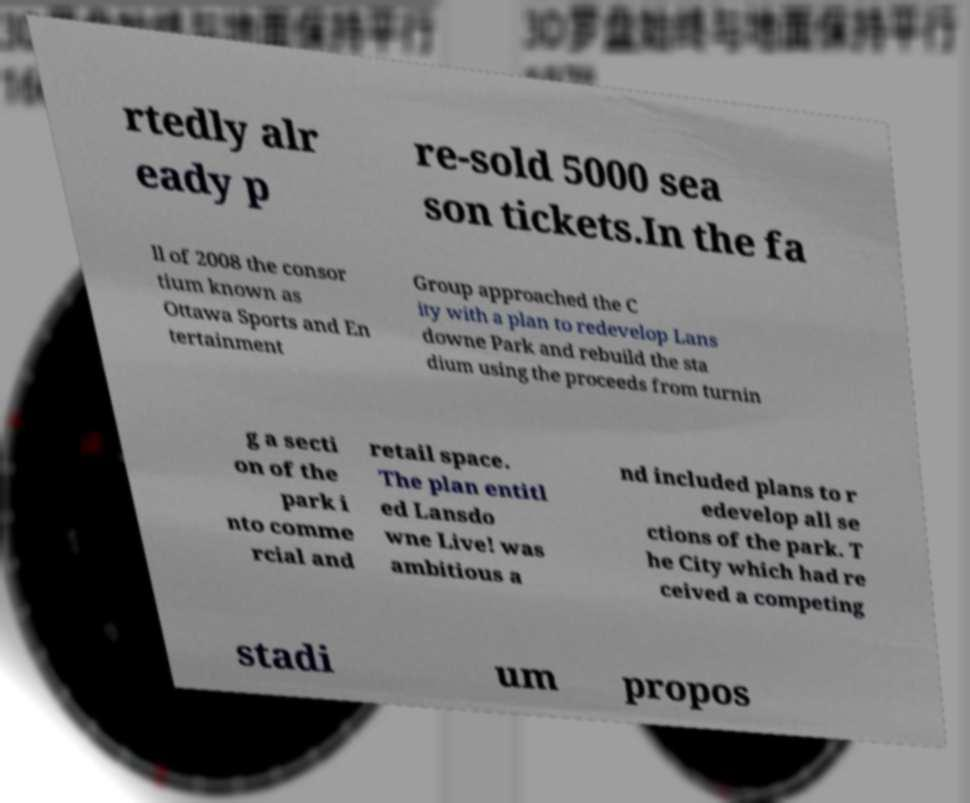Can you accurately transcribe the text from the provided image for me? rtedly alr eady p re-sold 5000 sea son tickets.In the fa ll of 2008 the consor tium known as Ottawa Sports and En tertainment Group approached the C ity with a plan to redevelop Lans downe Park and rebuild the sta dium using the proceeds from turnin g a secti on of the park i nto comme rcial and retail space. The plan entitl ed Lansdo wne Live! was ambitious a nd included plans to r edevelop all se ctions of the park. T he City which had re ceived a competing stadi um propos 